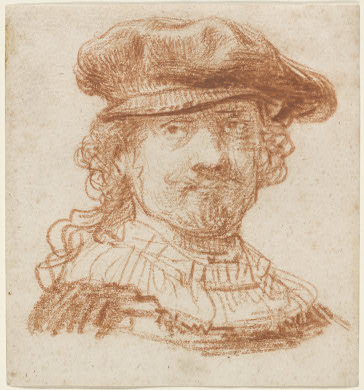What might indicate the social status or profession of this individual? The elaborate ruff collar and the detailed hat are indicative of high social status during the Baroque period. Such attire was commonly worn by those within the higher echelons of society, possibly suggesting that the individual portrayed might have been a person of considerable influence perhaps in a judicial or clerical position. 